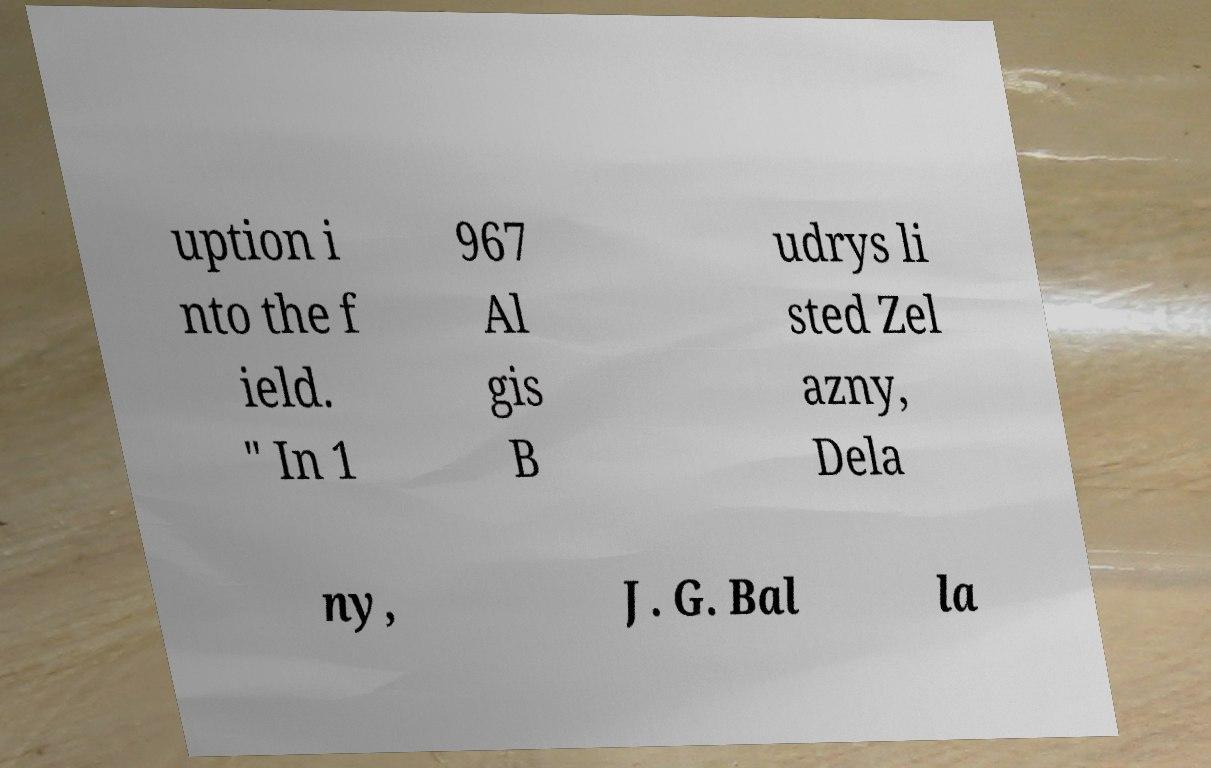There's text embedded in this image that I need extracted. Can you transcribe it verbatim? uption i nto the f ield. " In 1 967 Al gis B udrys li sted Zel azny, Dela ny, J. G. Bal la 